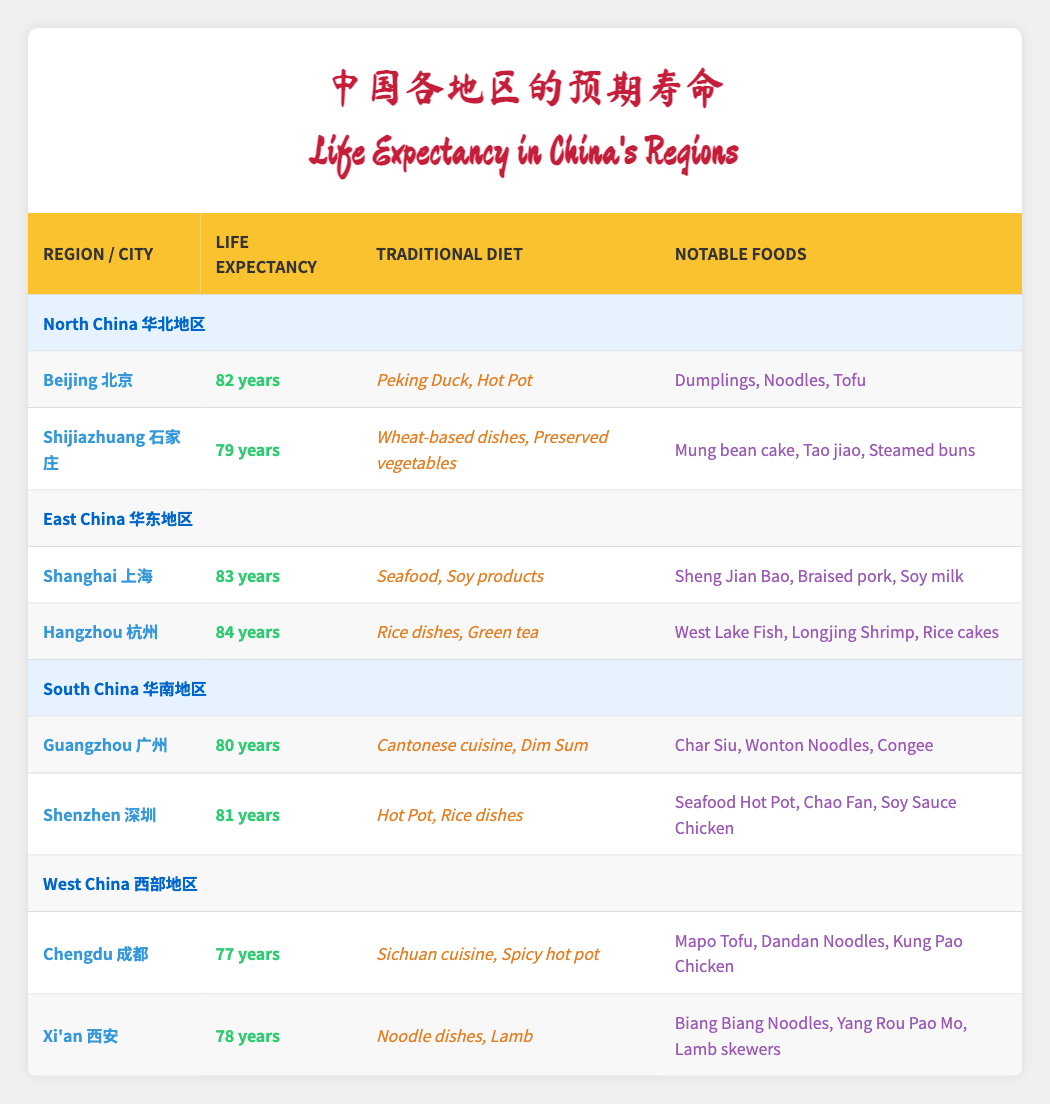What is the life expectancy in Shanghai? The table directly lists Shanghai's life expectancy as 83 years in the East China region.
Answer: 83 years Which region has the highest average life expectancy? To find the average, we calculate the total life expectancy for each region: North China (80.5), East China (83.5), South China (80.5), and West China (77.5). East China has the highest average at 83.5 years.
Answer: East China Is the life expectancy in Guangzhou greater than that in Chengdu? The life expectancy in Guangzhou is 80 years, while in Chengdu it is 77 years. Since 80 is greater than 77, the statement is true.
Answer: Yes What are the notable foods in Hangzhou? The notable foods listed for Hangzhou in the table include West Lake Fish, Longjing Shrimp, and Rice cakes.
Answer: West Lake Fish, Longjing Shrimp, Rice cakes Calculate the total life expectancy of all cities listed in South China. Add the life expectancy values of Guangzhou (80) and Shenzhen (81) to get a total of 80 + 81 = 161 years.
Answer: 161 years Does Shijiazhuang have a higher life expectancy than Xi'an? Shijiazhuang has a life expectancy of 79 years and Xi'an has 78 years. Since 79 is greater than 78, the answer is true.
Answer: Yes Which city in North China has the lowest life expectancy? By examining the data in the North China section, Shijiazhuang has a life expectancy of 79 years, while Beijing has 82 years. Therefore, Shijiazhuang has the lowest.
Answer: Shijiazhuang What traditional diet is associated with cities in South China? The traditional diets for cities in South China are listed: Guangzhou has Cantonese cuisine and Dim Sum, while Shenzhen has Hot Pot and rice dishes.
Answer: Cantonese cuisine, Dim Sum; Hot Pot, rice dishes What is the difference in life expectancy between Hangzhou and Xi'an? Hangzhou has a life expectancy of 84 years, and Xi'an has 78 years. To find the difference: 84 - 78 = 6 years.
Answer: 6 years 